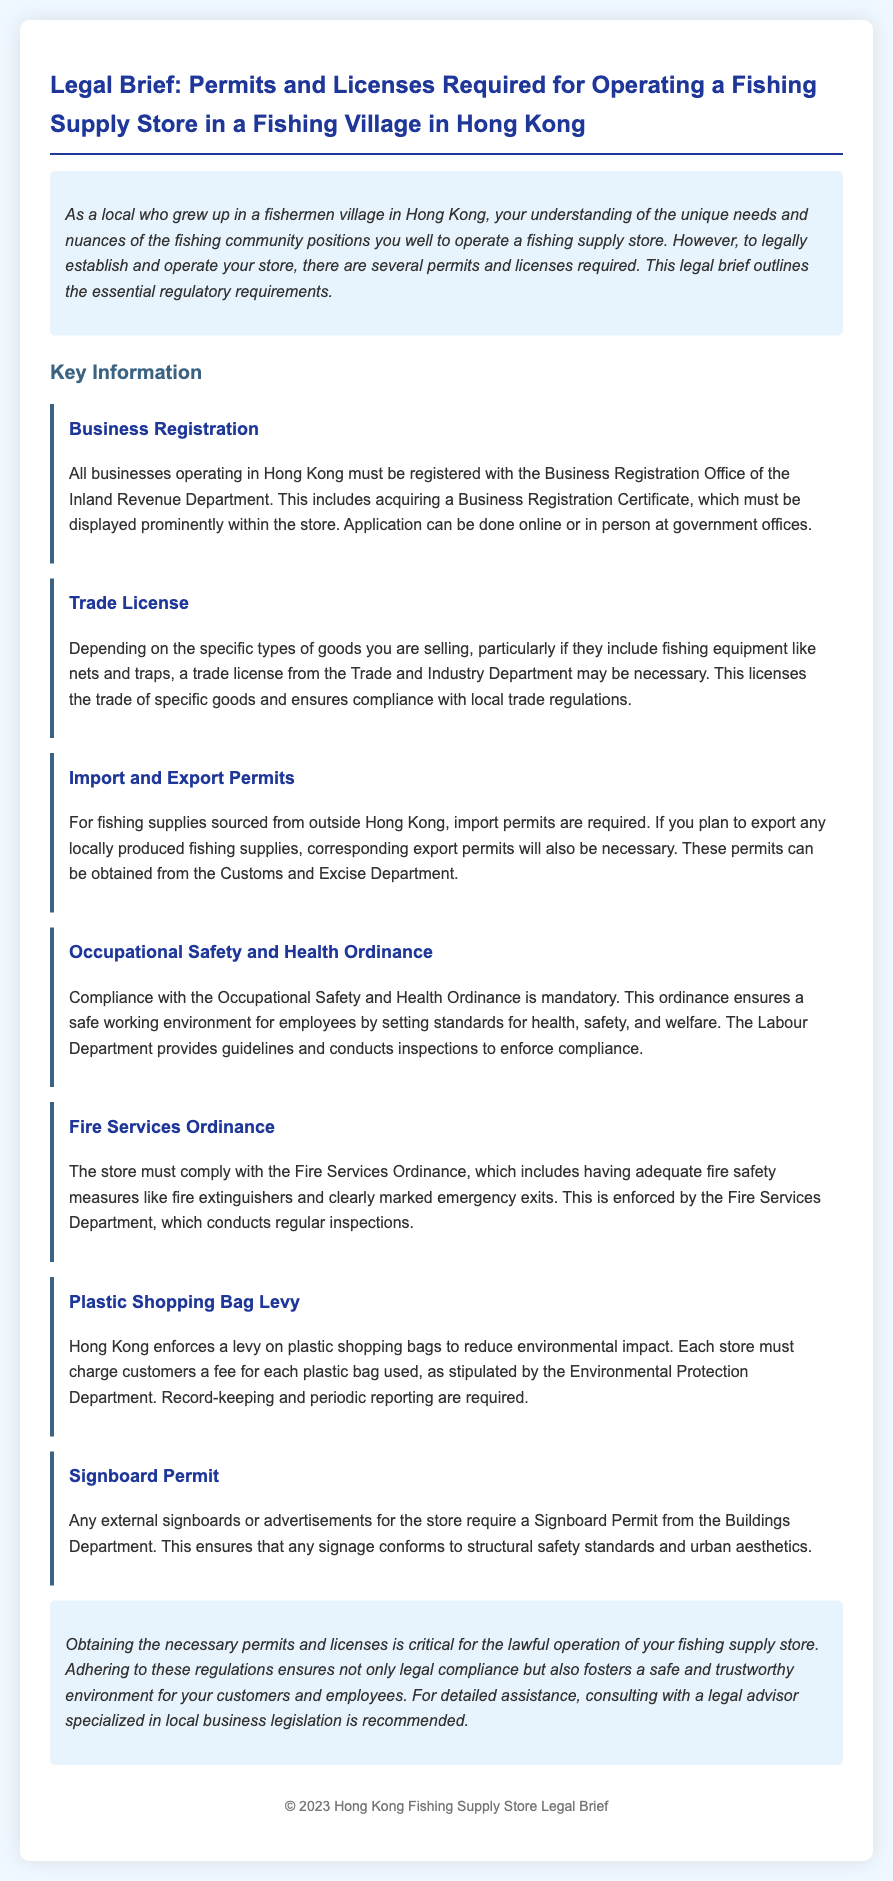What is required for business operation in Hong Kong? The document states that all businesses must be registered with the Business Registration Office and acquire a Business Registration Certificate.
Answer: Business Registration Certificate What department issues the trade license? The trade license is issued by the Trade and Industry Department according to the document.
Answer: Trade and Industry Department What ordinance ensures a safe working environment? The Occupational Safety and Health Ordinance is the regulation that ensures safety in the workplace.
Answer: Occupational Safety and Health Ordinance Which permit is necessary for imported fishing supplies? The document indicates that an import permit is required for fishing supplies sourced from outside Hong Kong.
Answer: Import permit What is the fee charged for in stores? The document mentions that stores must charge customers a fee for plastic shopping bags to reduce environmental impact.
Answer: Plastic shopping bags What must be displayed prominently in the store? According to the document, the Business Registration Certificate must be displayed prominently within the store.
Answer: Business Registration Certificate What does the Fire Services Ordinance relate to? The Fire Services Ordinance relates to having adequate fire safety measures in the store.
Answer: Fire safety measures What does a Signboard Permit ensure? A Signboard Permit ensures that any signage conforms to structural safety standards and urban aesthetics.
Answer: Structural safety standards What should be consulted for detailed assistance? The document recommends consulting a legal advisor specialized in local business legislation for detailed assistance.
Answer: Legal advisor 